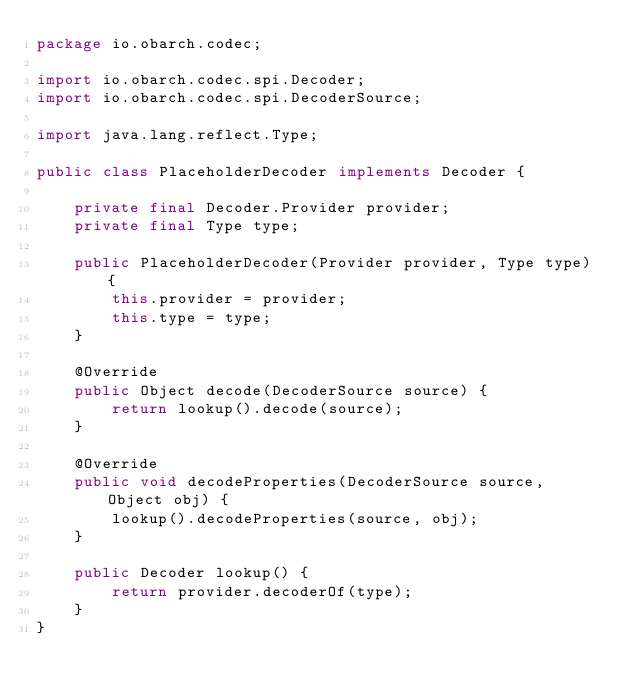Convert code to text. <code><loc_0><loc_0><loc_500><loc_500><_Java_>package io.obarch.codec;

import io.obarch.codec.spi.Decoder;
import io.obarch.codec.spi.DecoderSource;

import java.lang.reflect.Type;

public class PlaceholderDecoder implements Decoder {

    private final Decoder.Provider provider;
    private final Type type;

    public PlaceholderDecoder(Provider provider, Type type) {
        this.provider = provider;
        this.type = type;
    }

    @Override
    public Object decode(DecoderSource source) {
        return lookup().decode(source);
    }

    @Override
    public void decodeProperties(DecoderSource source, Object obj) {
        lookup().decodeProperties(source, obj);
    }

    public Decoder lookup() {
        return provider.decoderOf(type);
    }
}
</code> 